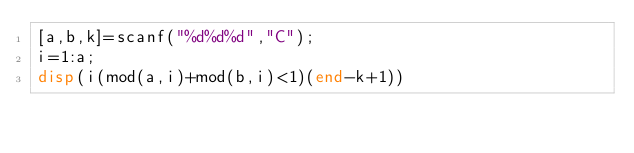Convert code to text. <code><loc_0><loc_0><loc_500><loc_500><_Octave_>[a,b,k]=scanf("%d%d%d","C");
i=1:a;
disp(i(mod(a,i)+mod(b,i)<1)(end-k+1))</code> 